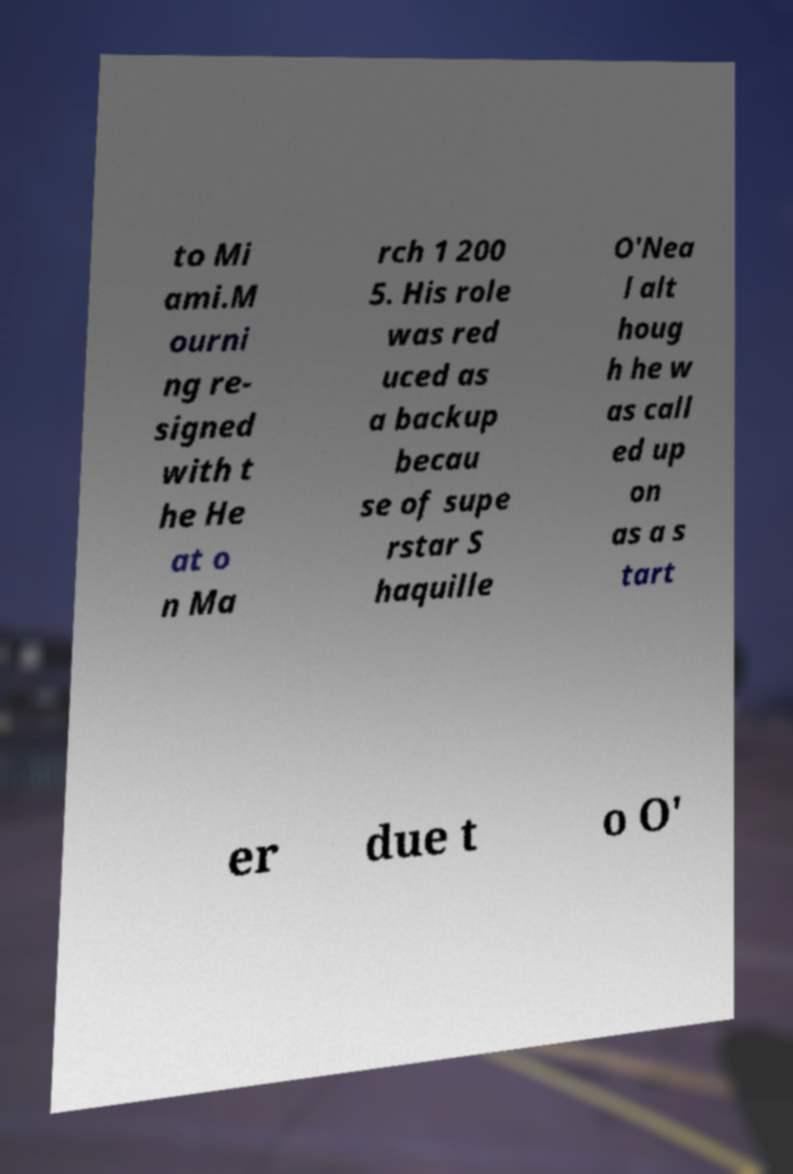For documentation purposes, I need the text within this image transcribed. Could you provide that? to Mi ami.M ourni ng re- signed with t he He at o n Ma rch 1 200 5. His role was red uced as a backup becau se of supe rstar S haquille O'Nea l alt houg h he w as call ed up on as a s tart er due t o O' 